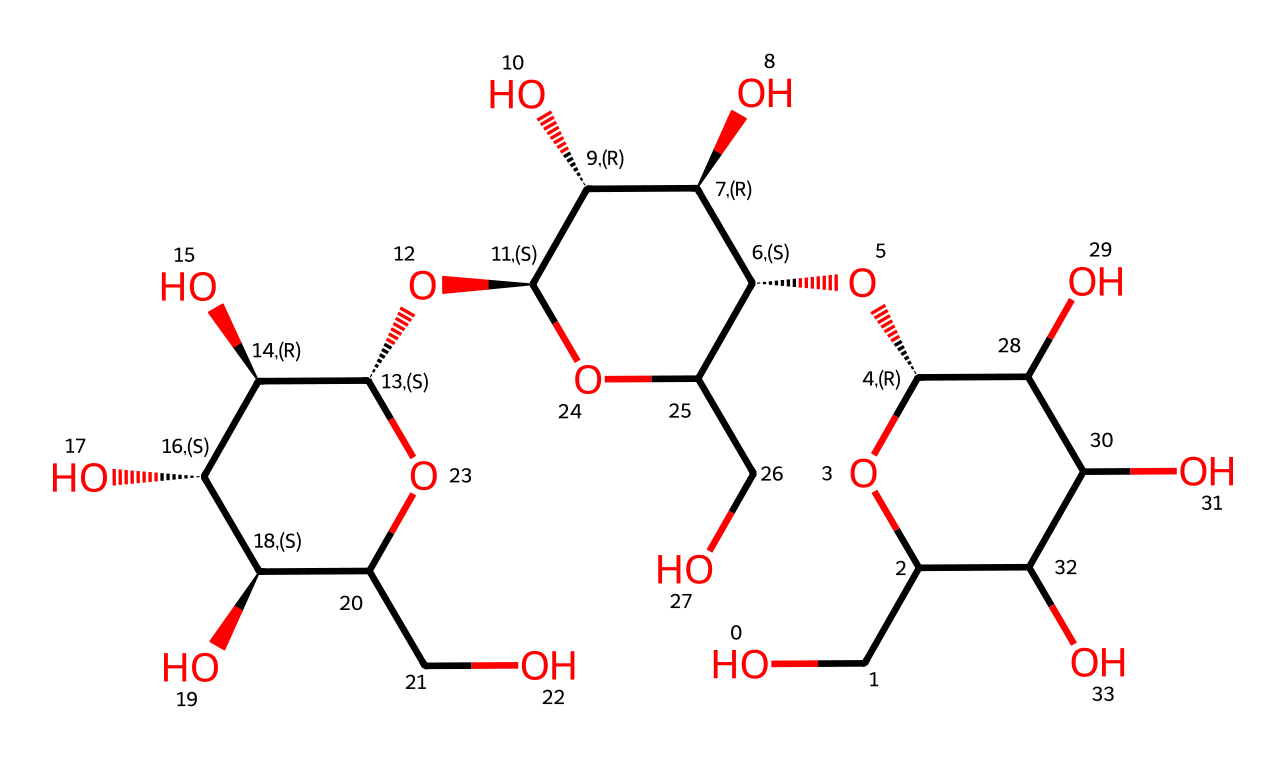What is the molecular formula of cellulose? The SMILES representation describes a polysaccharide (cellulose). To find the molecular formula, count the number of carbon (C), hydrogen (H), and oxygen (O) atoms in the structure. This particular structure has six carbons, ten hydrogens, and five oxygens, leading to the empirical formula C6H10O5.
Answer: C6H10O5 How many ring structures are present in cellulose? By analyzing the SMILES representation, we can see multiple segments that form rings (indicated by parentheses and the presence of C atoms creating cyclic structures). The structure includes three distinct ring structures connected through various functional groups.
Answer: three What type of carbohydrate is cellulose classified as? Cellulose is a polysaccharide because it consists of long chains of monosaccharide units (glucose). The structure is complex and larger than simple sugars, characterizing it as a polysaccharide.
Answer: polysaccharide What functional groups are present in cellulose? Examining the SMILES structure, we note that hydroxyl groups (-OH) are abundantly present throughout the molecule. These -OH groups are responsible for hydrogen bonding, contributing to cellulose's structure and properties.
Answer: hydroxyl groups How does cellulose contribute to plant structure? The numerous hydroxyl groups in cellulose allow for strong intermolecular hydrogen bonding, resulting in a rigid structure. This rigidity is essential for maintaining the integrity and strength of plant cell walls, which support plant growth.
Answer: rigidity What is the primary purpose of cellulose in nature? Cellulose primarily serves as a structural component in the cell walls of plants, providing support and protection. Its unique composition allows for strength and durability, making it crucial for plant structure and growth.
Answer: structural support 